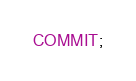Convert code to text. <code><loc_0><loc_0><loc_500><loc_500><_SQL_>COMMIT;
</code> 